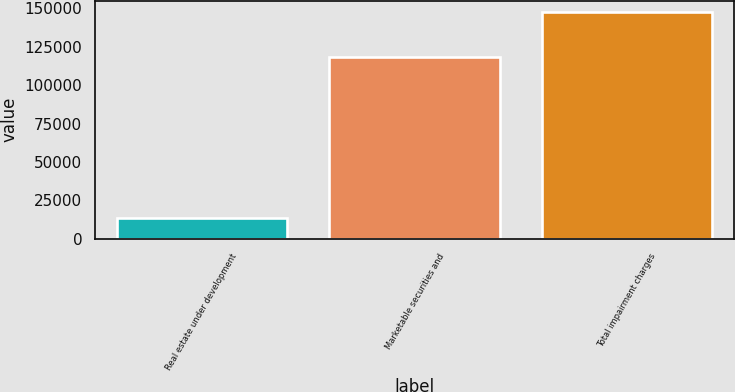<chart> <loc_0><loc_0><loc_500><loc_500><bar_chart><fcel>Real estate under development<fcel>Marketable securities and<fcel>Total impairment charges<nl><fcel>13613<fcel>118416<fcel>147529<nl></chart> 